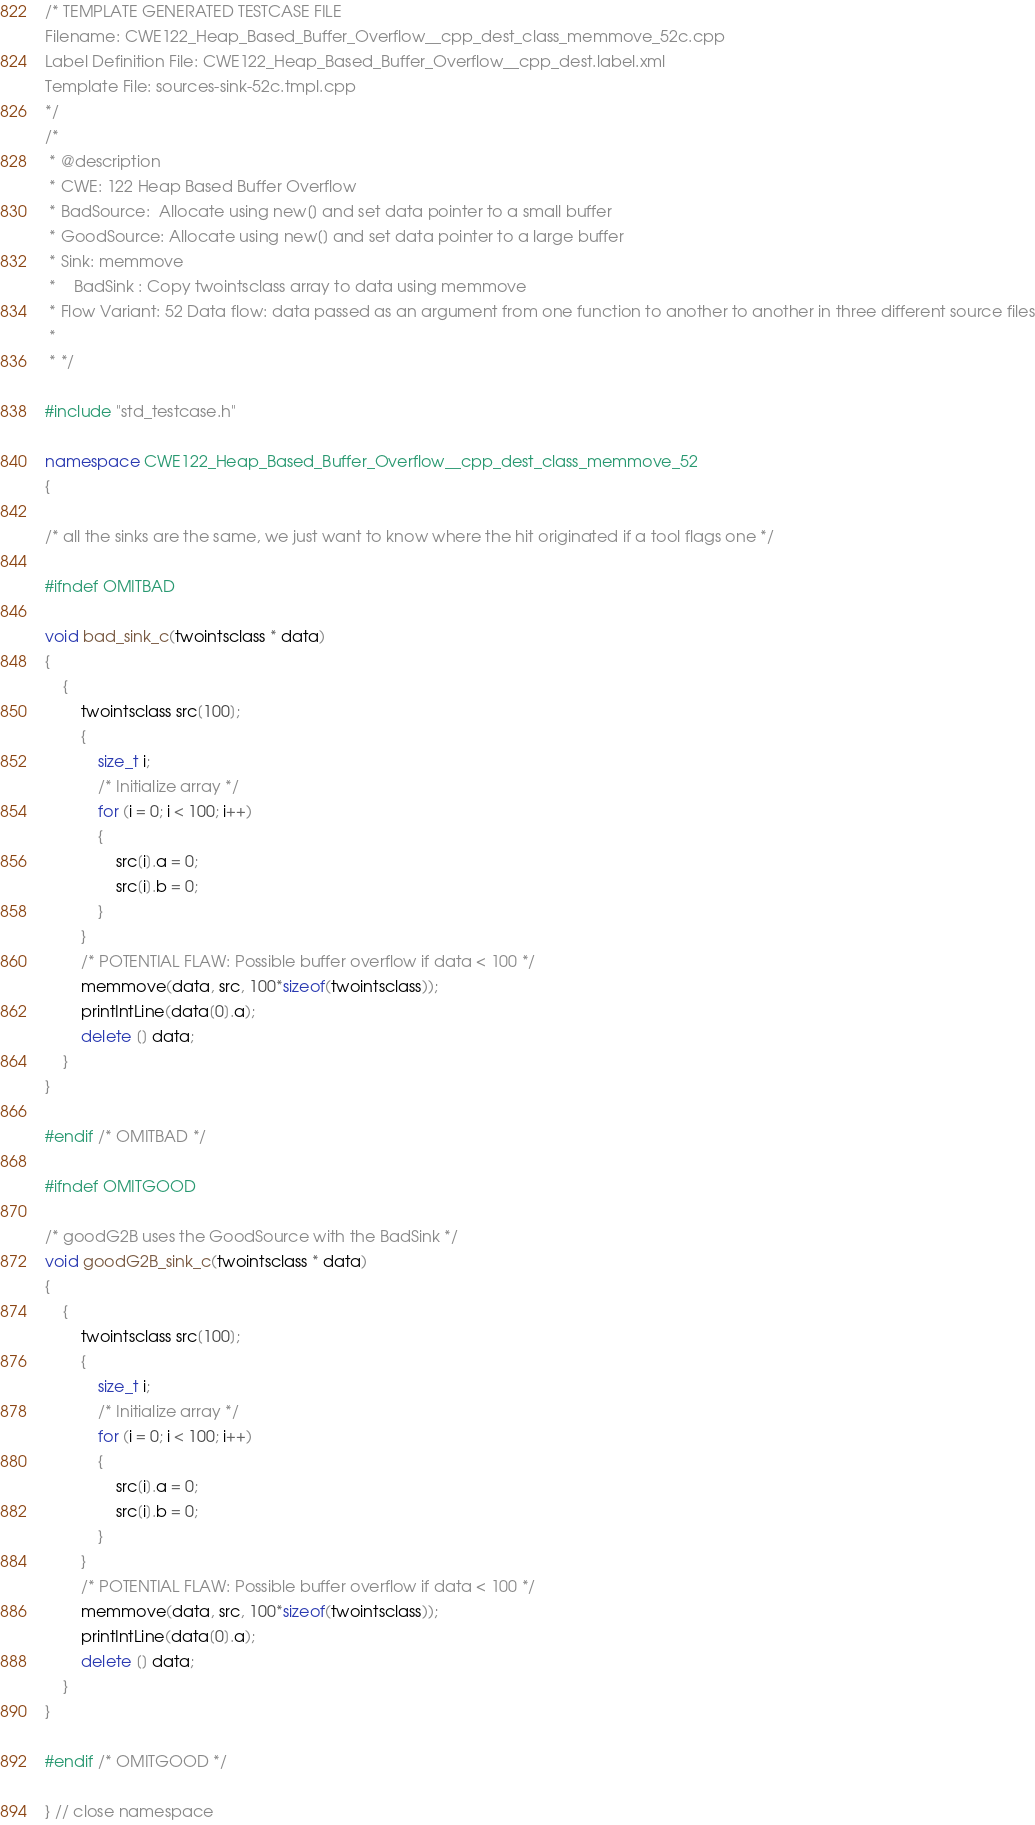Convert code to text. <code><loc_0><loc_0><loc_500><loc_500><_C++_>/* TEMPLATE GENERATED TESTCASE FILE
Filename: CWE122_Heap_Based_Buffer_Overflow__cpp_dest_class_memmove_52c.cpp
Label Definition File: CWE122_Heap_Based_Buffer_Overflow__cpp_dest.label.xml
Template File: sources-sink-52c.tmpl.cpp
*/
/*
 * @description
 * CWE: 122 Heap Based Buffer Overflow
 * BadSource:  Allocate using new[] and set data pointer to a small buffer
 * GoodSource: Allocate using new[] and set data pointer to a large buffer
 * Sink: memmove
 *    BadSink : Copy twointsclass array to data using memmove
 * Flow Variant: 52 Data flow: data passed as an argument from one function to another to another in three different source files
 *
 * */

#include "std_testcase.h"

namespace CWE122_Heap_Based_Buffer_Overflow__cpp_dest_class_memmove_52
{

/* all the sinks are the same, we just want to know where the hit originated if a tool flags one */

#ifndef OMITBAD

void bad_sink_c(twointsclass * data)
{
    {
        twointsclass src[100];
        {
            size_t i;
            /* Initialize array */
            for (i = 0; i < 100; i++)
            {
                src[i].a = 0;
                src[i].b = 0;
            }
        }
        /* POTENTIAL FLAW: Possible buffer overflow if data < 100 */
        memmove(data, src, 100*sizeof(twointsclass));
        printIntLine(data[0].a);
        delete [] data;
    }
}

#endif /* OMITBAD */

#ifndef OMITGOOD

/* goodG2B uses the GoodSource with the BadSink */
void goodG2B_sink_c(twointsclass * data)
{
    {
        twointsclass src[100];
        {
            size_t i;
            /* Initialize array */
            for (i = 0; i < 100; i++)
            {
                src[i].a = 0;
                src[i].b = 0;
            }
        }
        /* POTENTIAL FLAW: Possible buffer overflow if data < 100 */
        memmove(data, src, 100*sizeof(twointsclass));
        printIntLine(data[0].a);
        delete [] data;
    }
}

#endif /* OMITGOOD */

} // close namespace
</code> 